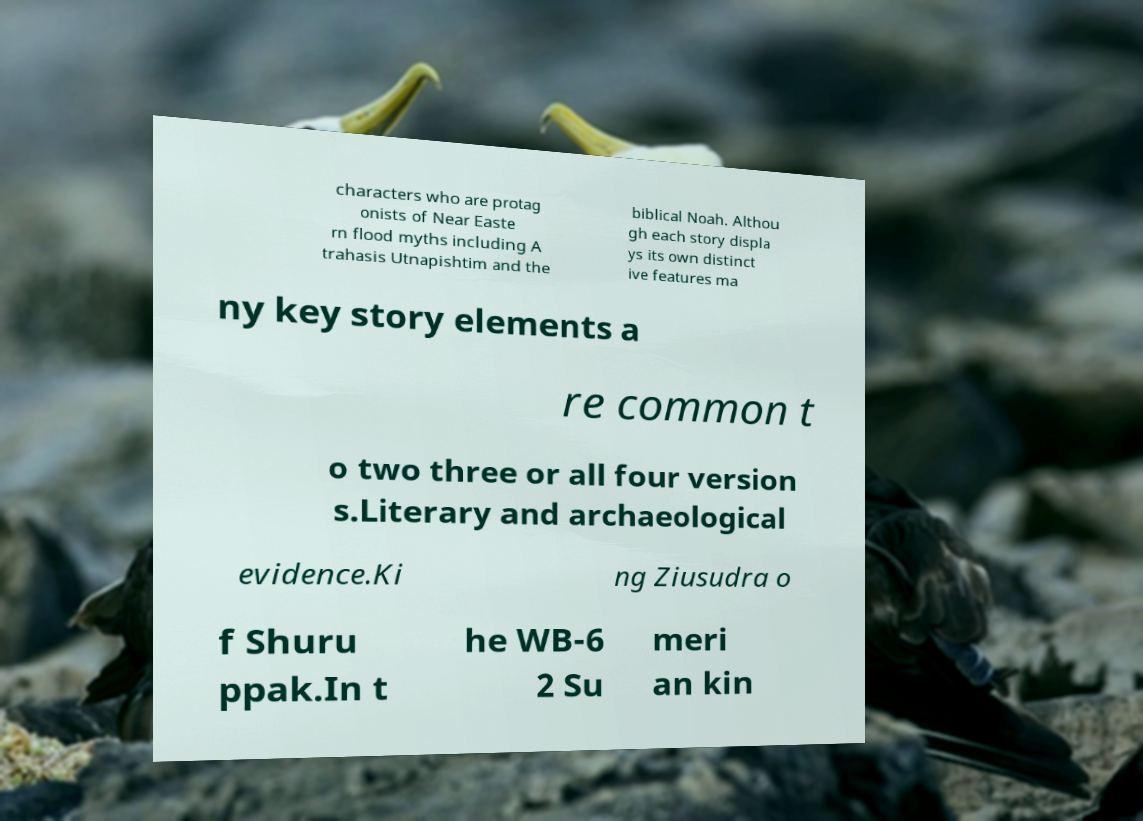Can you read and provide the text displayed in the image?This photo seems to have some interesting text. Can you extract and type it out for me? characters who are protag onists of Near Easte rn flood myths including A trahasis Utnapishtim and the biblical Noah. Althou gh each story displa ys its own distinct ive features ma ny key story elements a re common t o two three or all four version s.Literary and archaeological evidence.Ki ng Ziusudra o f Shuru ppak.In t he WB-6 2 Su meri an kin 